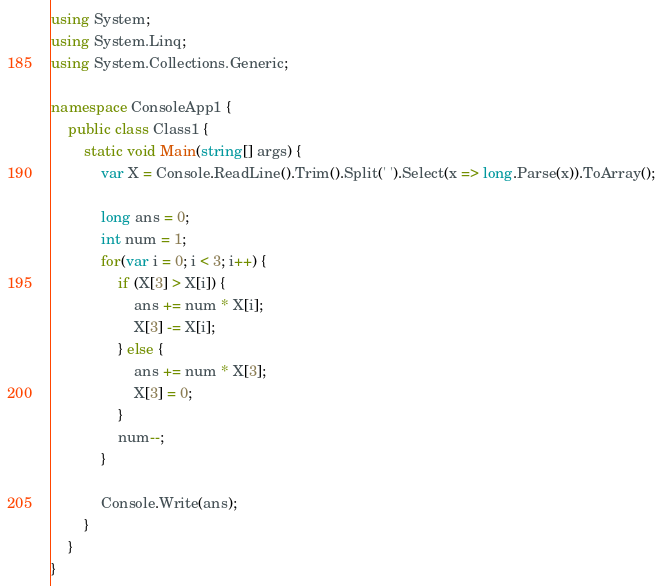<code> <loc_0><loc_0><loc_500><loc_500><_C#_>using System;
using System.Linq;
using System.Collections.Generic;

namespace ConsoleApp1 {
    public class Class1 {
        static void Main(string[] args) {
            var X = Console.ReadLine().Trim().Split(' ').Select(x => long.Parse(x)).ToArray();

            long ans = 0;
            int num = 1;
            for(var i = 0; i < 3; i++) {
                if (X[3] > X[i]) {
                    ans += num * X[i];
                    X[3] -= X[i];
                } else {
                    ans += num * X[3];
                    X[3] = 0;
                }
                num--;
            }

            Console.Write(ans);
        }
    }
}</code> 